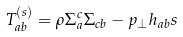Convert formula to latex. <formula><loc_0><loc_0><loc_500><loc_500>T _ { a b } ^ { \left ( s \right ) } = \rho \Sigma _ { a } ^ { c } \Sigma _ { c b } - p _ { \bot } h _ { a b } s</formula> 